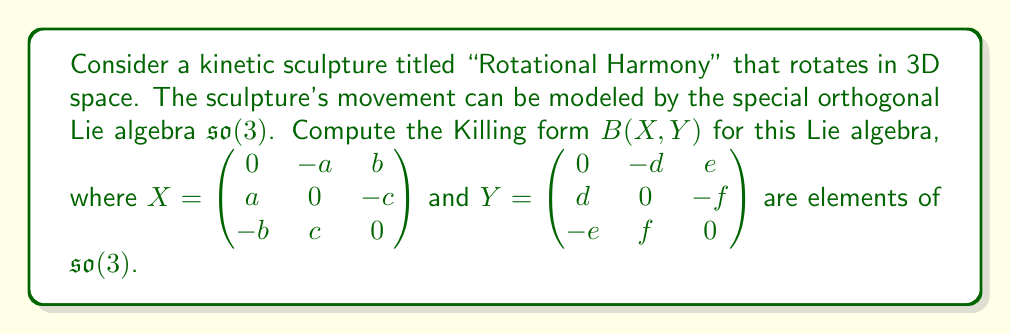Help me with this question. To compute the Killing form for the Lie algebra $\mathfrak{so}(3)$, we follow these steps:

1) The Killing form is defined as $B(X,Y) = \text{tr}(\text{ad}(X) \circ \text{ad}(Y))$, where $\text{ad}$ denotes the adjoint representation and $\text{tr}$ is the trace.

2) For $\mathfrak{so}(3)$, we can use a simpler formula: $B(X,Y) = -2\text{tr}(XY)$.

3) Let's multiply $X$ and $Y$:

   $$XY = \begin{pmatrix} 
   0 & -a & b \\ 
   a & 0 & -c \\ 
   -b & c & 0
   \end{pmatrix}
   \begin{pmatrix}
   0 & -d & e \\
   d & 0 & -f \\
   -e & f & 0
   \end{pmatrix}$$

   $$= \begin{pmatrix}
   -ad-be & -af+bd & -ae-cf \\
   ae+cd & -ad-cf & -bf+cd \\
   -af+be & bf+ce & -be-cf
   \end{pmatrix}$$

4) Now, we need to calculate the trace of this matrix, which is the sum of its diagonal elements:

   $\text{tr}(XY) = (-ad-be) + (-ad-cf) + (-be-cf)$
                 $= -2ad - 2be - 2cf$

5) Finally, we apply the formula $B(X,Y) = -2\text{tr}(XY)$:

   $B(X,Y) = -2(-2ad - 2be - 2cf) = 4ad + 4be + 4cf$

This result represents the Killing form for the given elements $X$ and $Y$ in $\mathfrak{so}(3)$, which models the rotation of the kinetic sculpture "Rotational Harmony".
Answer: $B(X,Y) = 4ad + 4be + 4cf$ 